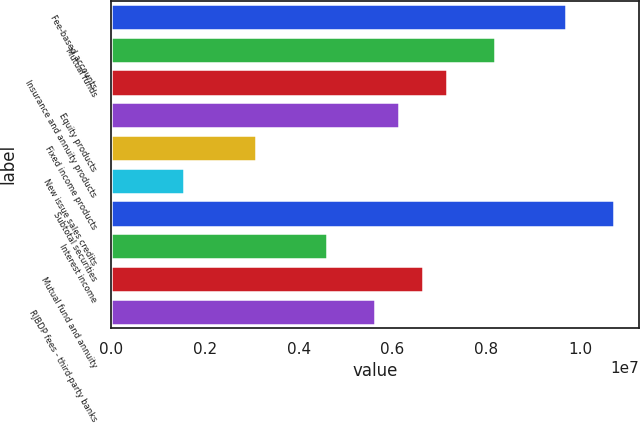Convert chart. <chart><loc_0><loc_0><loc_500><loc_500><bar_chart><fcel>Fee-based accounts<fcel>Mutual funds<fcel>Insurance and annuity products<fcel>Equity products<fcel>Fixed income products<fcel>New issue sales credits<fcel>Subtotal securities<fcel>Interest income<fcel>Mutual fund and annuity<fcel>RJBDP fees - third-party banks<nl><fcel>9.70919e+06<fcel>8.17973e+06<fcel>7.1601e+06<fcel>6.14047e+06<fcel>3.08156e+06<fcel>1.55211e+06<fcel>1.07288e+07<fcel>4.61101e+06<fcel>6.65028e+06<fcel>5.63065e+06<nl></chart> 